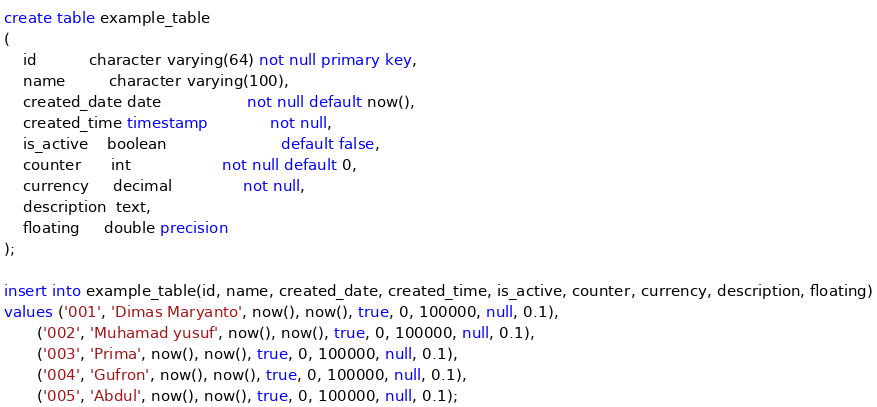Convert code to text. <code><loc_0><loc_0><loc_500><loc_500><_SQL_>create table example_table
(
    id           character varying(64) not null primary key,
    name         character varying(100),
    created_date date                  not null default now(),
    created_time timestamp             not null,
    is_active    boolean                        default false,
    counter      int                   not null default 0,
    currency     decimal               not null,
    description  text,
    floating     double precision
);

insert into example_table(id, name, created_date, created_time, is_active, counter, currency, description, floating)
values ('001', 'Dimas Maryanto', now(), now(), true, 0, 100000, null, 0.1),
       ('002', 'Muhamad yusuf', now(), now(), true, 0, 100000, null, 0.1),
       ('003', 'Prima', now(), now(), true, 0, 100000, null, 0.1),
       ('004', 'Gufron', now(), now(), true, 0, 100000, null, 0.1),
       ('005', 'Abdul', now(), now(), true, 0, 100000, null, 0.1);
</code> 